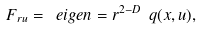<formula> <loc_0><loc_0><loc_500><loc_500>F _ { r u } = \ e i g e n = r ^ { 2 - D } \ q ( x , u ) ,</formula> 